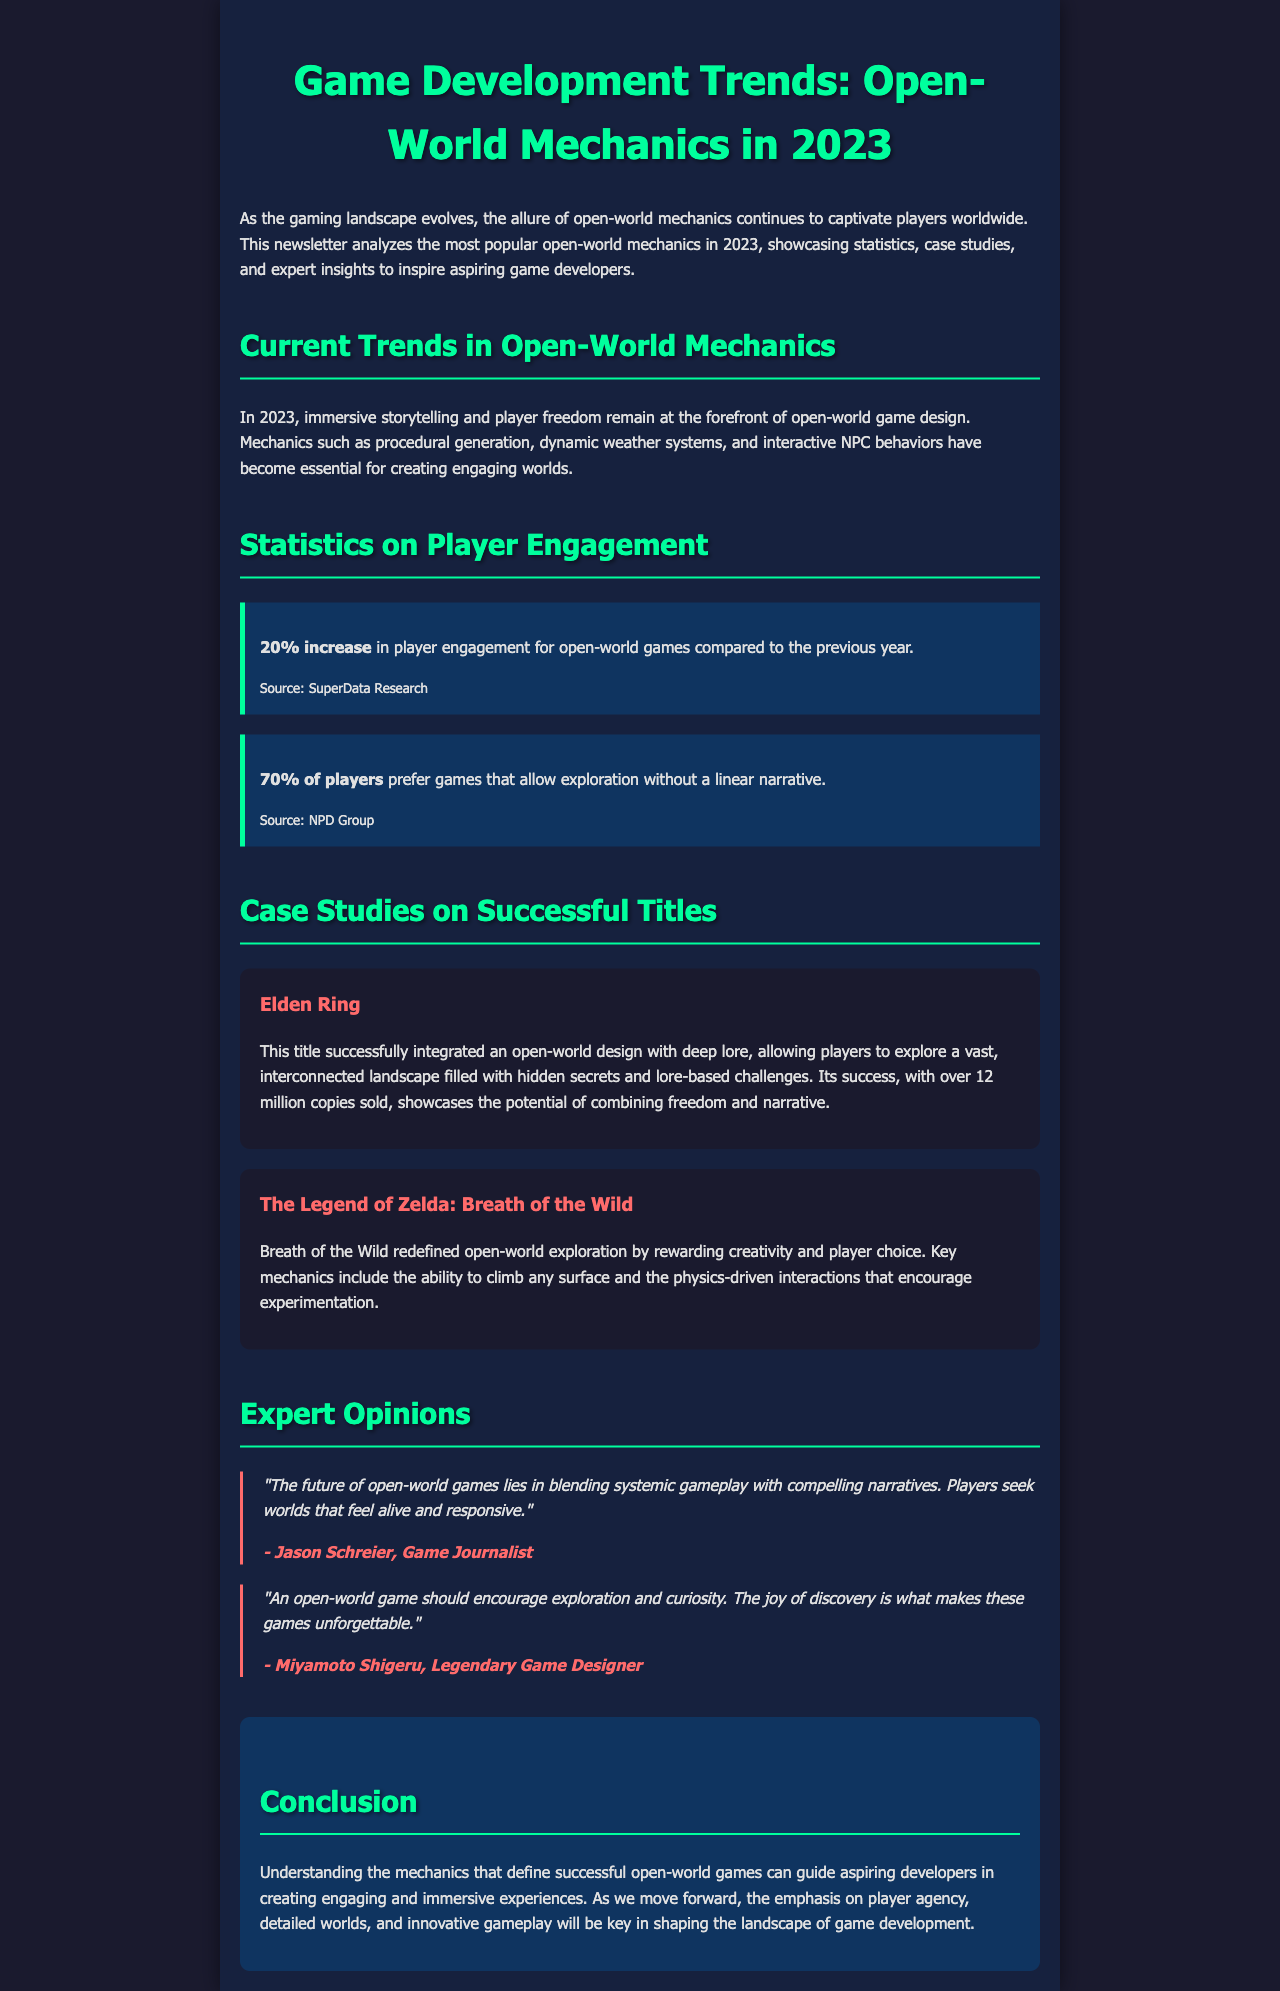What is the primary focus of open-world game design in 2023? The document states that immersive storytelling and player freedom are at the forefront of open-world game design.
Answer: Immersive storytelling and player freedom How much has player engagement increased for open-world games in 2023? According to the document, there is a 20% increase in player engagement for open-world games compared to the previous year.
Answer: 20% What percentage of players prefer exploration without a linear narrative? The document indicates that 70% of players prefer games that allow exploration without a linear narrative.
Answer: 70% Which game sold over 12 million copies? The document mentions that Elden Ring has over 12 million copies sold.
Answer: Elden Ring What key mechanic does The Legend of Zelda: Breath of the Wild emphasize? The document highlights that a key mechanic of Breath of the Wild includes the ability to climb any surface.
Answer: Ability to climb any surface Who is the game journalist quoted in the document? The document quotes Jason Schreier as the game journalist providing expert opinion.
Answer: Jason Schreier What is the overarching theme of the expert opinions in the newsletter? The expert opinions emphasize the importance of blending systemic gameplay with compelling narratives.
Answer: Blending systemic gameplay with compelling narratives What does the conclusion suggest is key for shaping the landscape of game development? The conclusion states that the emphasis on player agency, detailed worlds, and innovative gameplay will be key.
Answer: Player agency, detailed worlds, innovative gameplay 